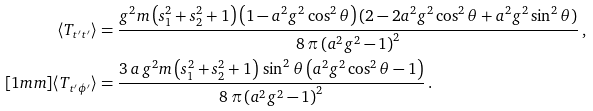Convert formula to latex. <formula><loc_0><loc_0><loc_500><loc_500>\langle T _ { t ^ { \prime } t ^ { \prime } } \rangle & = \frac { g ^ { 2 } m \left ( s _ { 1 } ^ { 2 } + s _ { 2 } ^ { 2 } + 1 \right ) \left ( 1 - a ^ { 2 } g ^ { 2 } \cos ^ { 2 } \theta \right ) ( 2 - 2 a ^ { 2 } g ^ { 2 } \cos ^ { 2 } \theta + a ^ { 2 } g ^ { 2 } \sin ^ { 2 } \theta ) } { 8 \, \pi \left ( a ^ { 2 } g ^ { 2 } - 1 \right ) ^ { 2 } } \, , \\ [ 1 m m ] \langle T _ { t ^ { \prime } \phi ^ { \prime } } \rangle & = \frac { 3 \, a \, g ^ { 2 } m \left ( s _ { 1 } ^ { 2 } + s _ { 2 } ^ { 2 } + 1 \right ) \, \sin ^ { 2 } { \theta } \left ( a ^ { 2 } g ^ { 2 } \cos ^ { 2 } \theta - 1 \right ) } { 8 \, \pi \left ( a ^ { 2 } g ^ { 2 } - 1 \right ) ^ { 2 } } \, .</formula> 